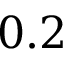Convert formula to latex. <formula><loc_0><loc_0><loc_500><loc_500>0 . 2</formula> 